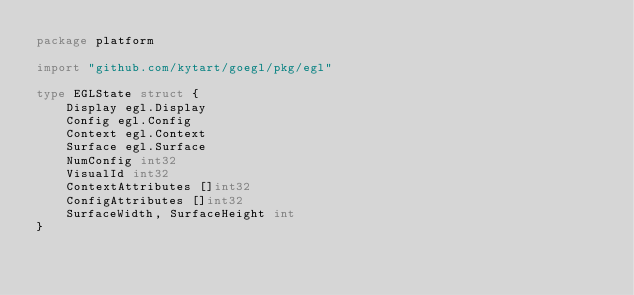<code> <loc_0><loc_0><loc_500><loc_500><_Go_>package platform

import "github.com/kytart/goegl/pkg/egl"

type EGLState struct {
	Display egl.Display
	Config egl.Config
	Context egl.Context
	Surface egl.Surface
	NumConfig int32
	VisualId int32
	ContextAttributes []int32
	ConfigAttributes []int32
	SurfaceWidth, SurfaceHeight int
}

</code> 